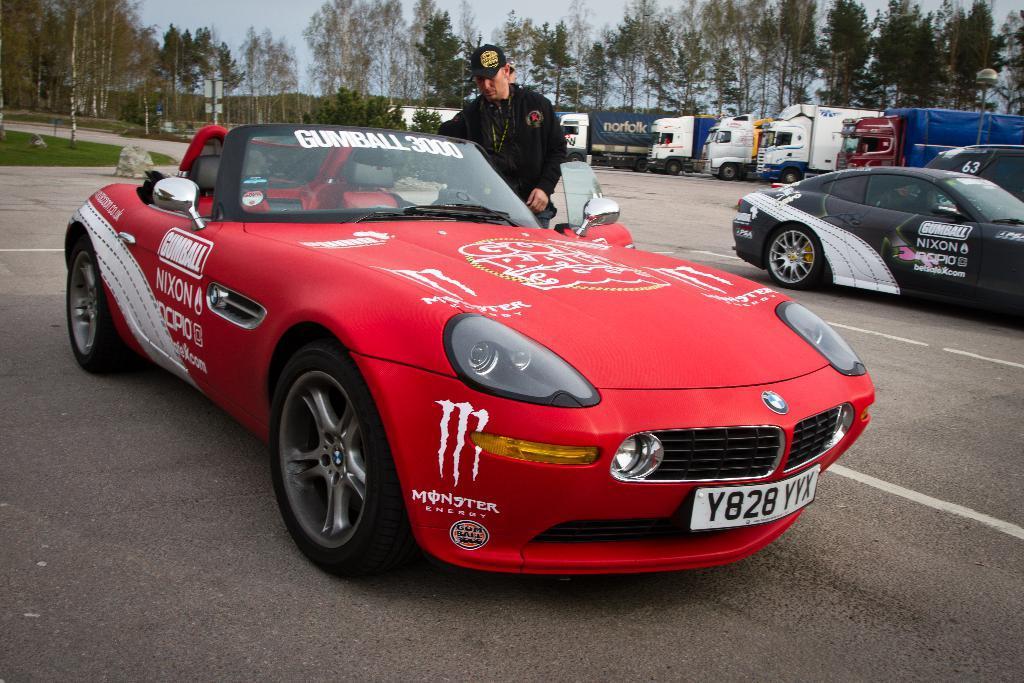How would you summarize this image in a sentence or two? In this image in front there is a car. Beside the car there is a person and there are a few other vehicles parked on the road. In the background of the image there are trees and sky. On the left side of the image there is grass on the surface. 